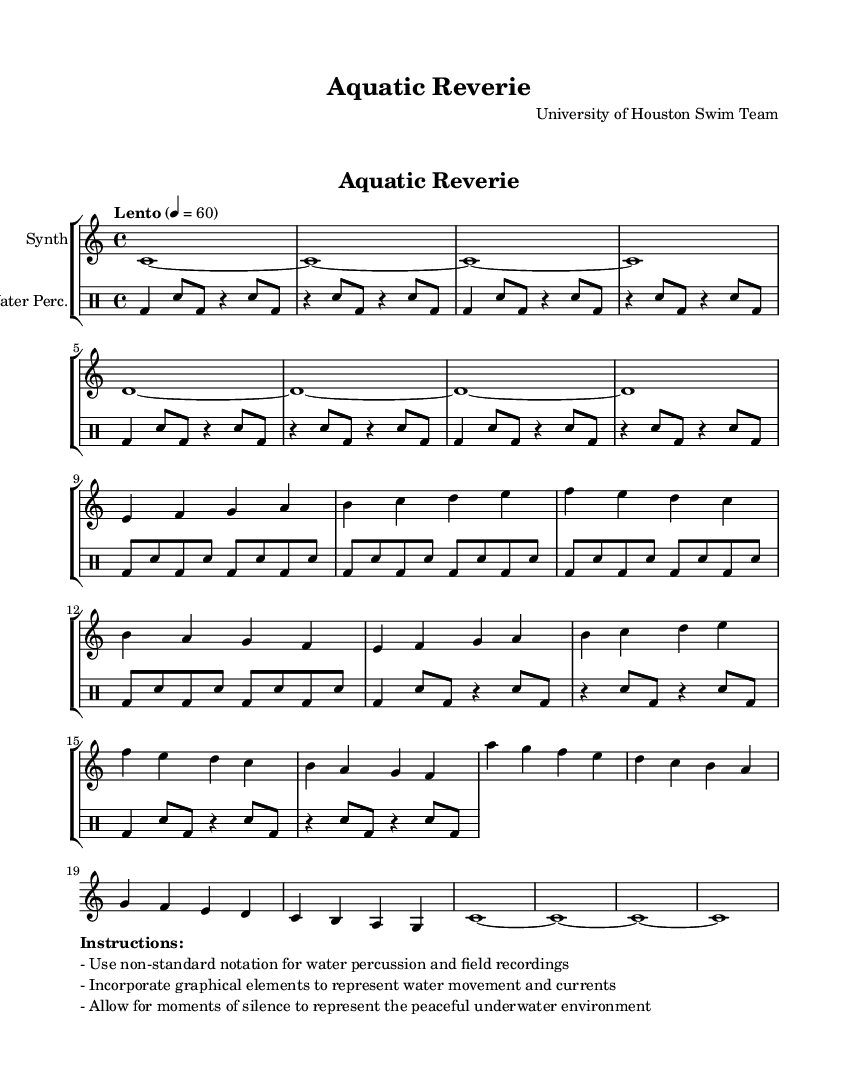What is the key signature of this music? The key signature is C major, as indicated by the music notation, which has no sharps or flats.
Answer: C major What is the time signature of this music? The time signature is 4/4, shown at the beginning of the piece where it indicates the meter as four beats per measure.
Answer: 4/4 What is the tempo marking of the piece? The tempo marking is "Lento", signifying a slow pace, and the equals sign indicates a specific speed of 60 beats per minute.
Answer: Lento How many measures are in the Main Theme section? The Main Theme section consists of 8 measures, identifiable by how the music is structured without repeating any pattern immediately.
Answer: 8 measures What type of instrumentation is used in this piece? The instrumentation consists of a synthesizer and a drum staff, indicated in the score where each part is labeled.
Answer: Synthesizer and drum staff What specific performance instructions are given for this piece? The instructions emphasize using non-standard notation for water percussion, and graphical elements to represent water movement and currents, allowing for moments of silence.
Answer: Non-standard notation, graphical elements, moments of silence What is the purpose of incorporating silence in this composition? The moments of silence are meant to represent the peaceful underwater environment, which enhances the ambient nature of the soundscape during training.
Answer: Peaceful underwater environment 